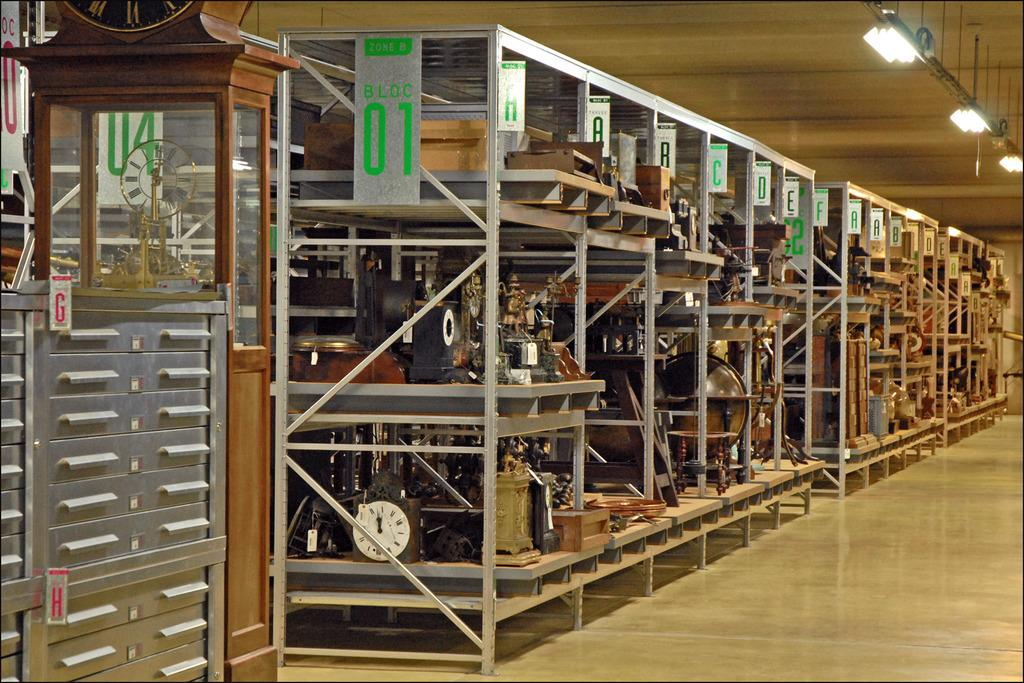Provide a one-sentence caption for the provided image. a warehouse with shelves numbered block 01 and A, B. 